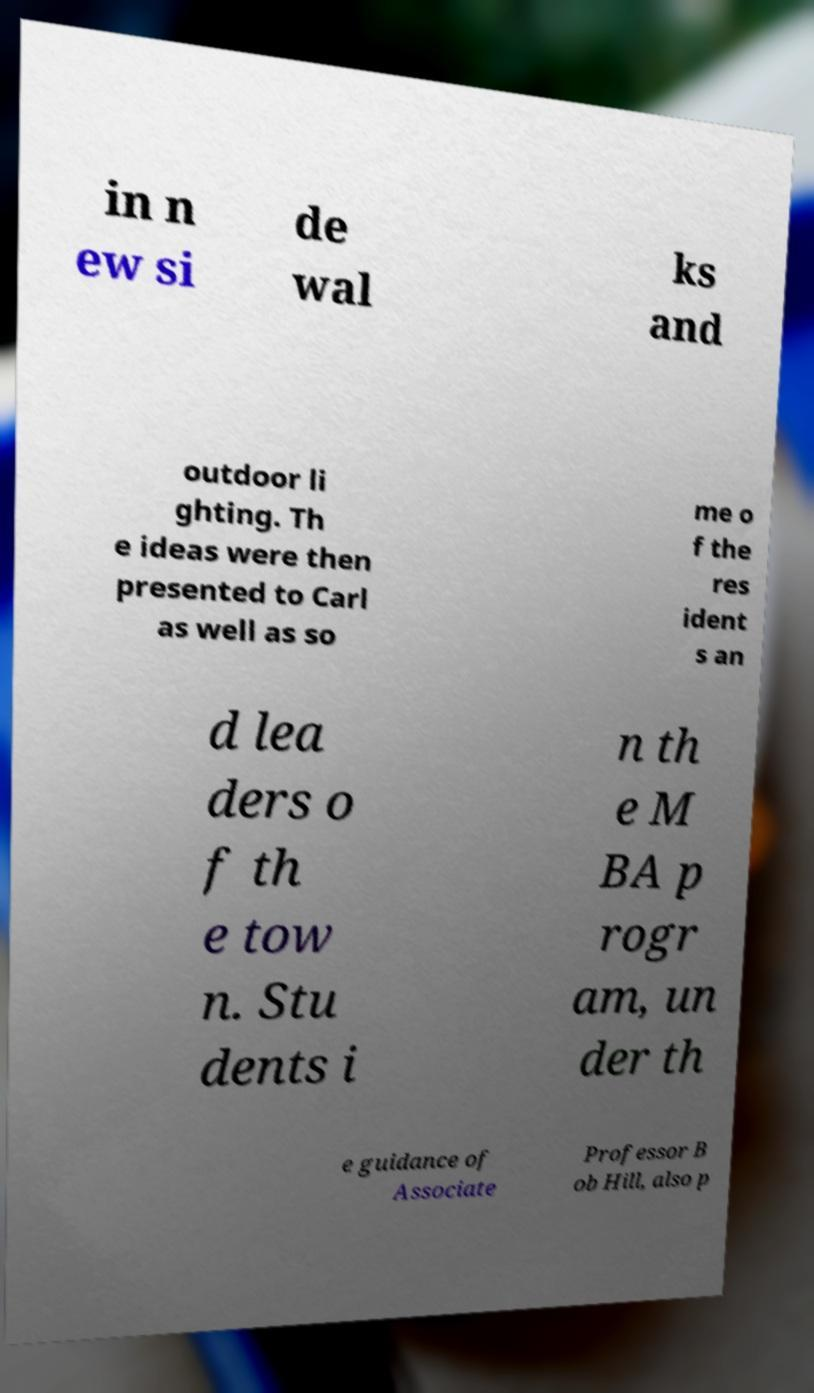What messages or text are displayed in this image? I need them in a readable, typed format. in n ew si de wal ks and outdoor li ghting. Th e ideas were then presented to Carl as well as so me o f the res ident s an d lea ders o f th e tow n. Stu dents i n th e M BA p rogr am, un der th e guidance of Associate Professor B ob Hill, also p 